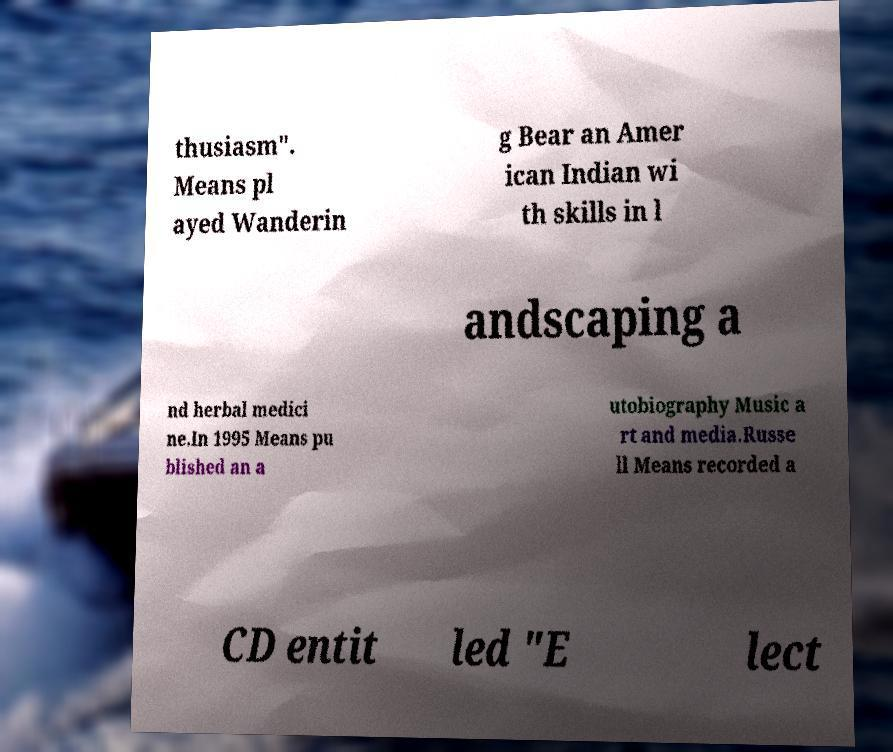For documentation purposes, I need the text within this image transcribed. Could you provide that? thusiasm". Means pl ayed Wanderin g Bear an Amer ican Indian wi th skills in l andscaping a nd herbal medici ne.In 1995 Means pu blished an a utobiography Music a rt and media.Russe ll Means recorded a CD entit led "E lect 